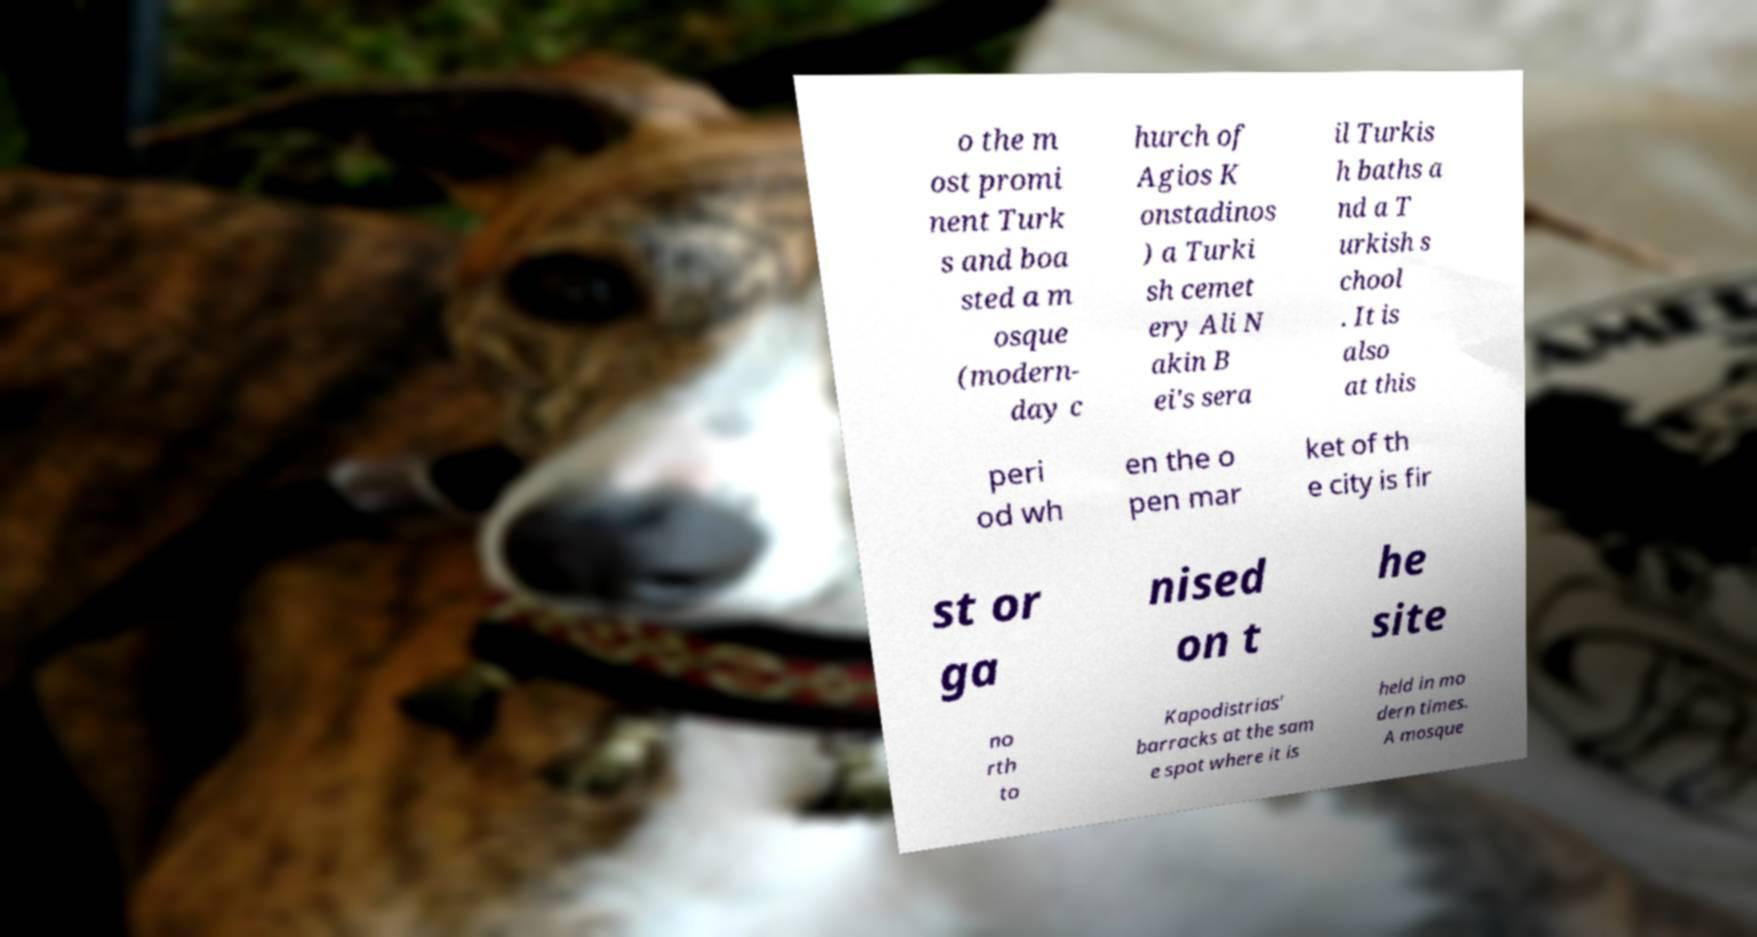Please identify and transcribe the text found in this image. o the m ost promi nent Turk s and boa sted a m osque (modern- day c hurch of Agios K onstadinos ) a Turki sh cemet ery Ali N akin B ei's sera il Turkis h baths a nd a T urkish s chool . It is also at this peri od wh en the o pen mar ket of th e city is fir st or ga nised on t he site no rth to Kapodistrias' barracks at the sam e spot where it is held in mo dern times. A mosque 